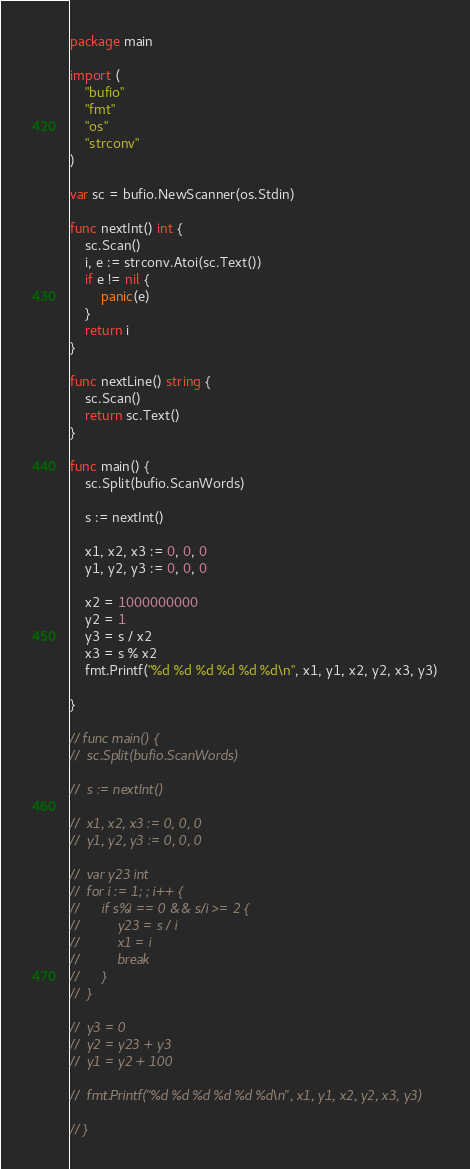<code> <loc_0><loc_0><loc_500><loc_500><_Go_>package main

import (
	"bufio"
	"fmt"
	"os"
	"strconv"
)

var sc = bufio.NewScanner(os.Stdin)

func nextInt() int {
	sc.Scan()
	i, e := strconv.Atoi(sc.Text())
	if e != nil {
		panic(e)
	}
	return i
}

func nextLine() string {
	sc.Scan()
	return sc.Text()
}

func main() {
	sc.Split(bufio.ScanWords)

	s := nextInt()

	x1, x2, x3 := 0, 0, 0
	y1, y2, y3 := 0, 0, 0

	x2 = 1000000000
	y2 = 1
	y3 = s / x2
	x3 = s % x2
	fmt.Printf("%d %d %d %d %d %d\n", x1, y1, x2, y2, x3, y3)

}

// func main() {
// 	sc.Split(bufio.ScanWords)

// 	s := nextInt()

// 	x1, x2, x3 := 0, 0, 0
// 	y1, y2, y3 := 0, 0, 0

// 	var y23 int
// 	for i := 1; ; i++ {
// 		if s%i == 0 && s/i >= 2 {
// 			y23 = s / i
// 			x1 = i
// 			break
// 		}
// 	}

// 	y3 = 0
// 	y2 = y23 + y3
// 	y1 = y2 + 100

// 	fmt.Printf("%d %d %d %d %d %d\n", x1, y1, x2, y2, x3, y3)

// }
</code> 